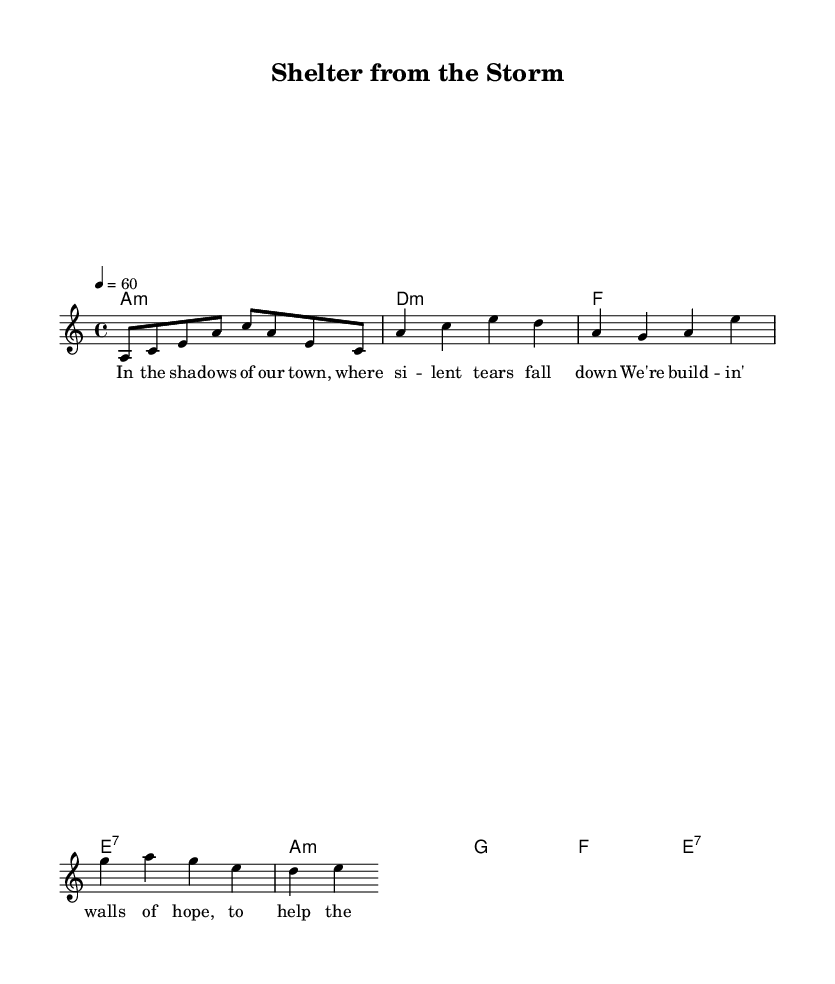what key is this music in? The key is indicated at the beginning of the score as "a minor," which is shown with the signature of one flat.
Answer: a minor what is the time signature? The time signature is displayed at the beginning of the score, showing "4/4," which means there are four beats per measure.
Answer: 4/4 what is the tempo marking for this piece? The tempo is indicated as "4 = 60," meaning that there are 60 beats per minute in quarter note timing, making it a slow tempo.
Answer: 60 which chord appears the most in the verse? By looking at the chord progression in the verse, "a minor" appears twice, while other chords appear only once.
Answer: a minor how many measures are there in the chorus? The chorus section contains four lines with a total of four measures as indicated by the chord changes.
Answer: four measures what style do we see reflected in this piece? The overall structure, emotional themes of support and healing, and use of blues chords are characteristic of electric blues.
Answer: electric blues what is the lyrical theme of the first verse? The theme focuses on community support, emphasizing building hope and coping with brokenness in the community.
Answer: community support 